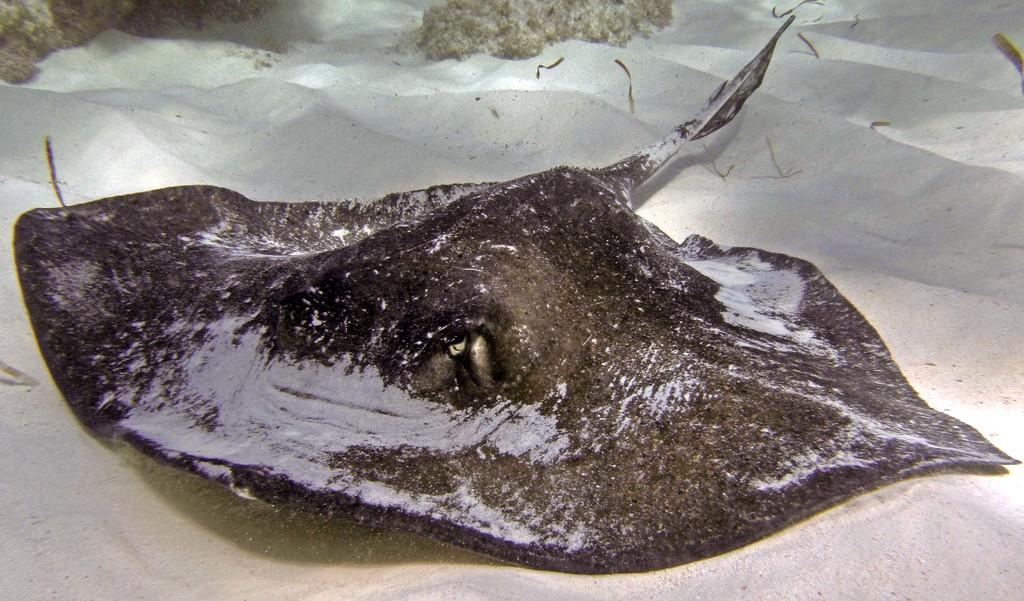What type of animal is in the image? There is a stingray in the image. What is the stingray resting on? The stingray is on white sand. What advice does the stingray give to the viewer in the image? The stingray does not give any advice in the image, as it is an animal and cannot speak or provide advice. 